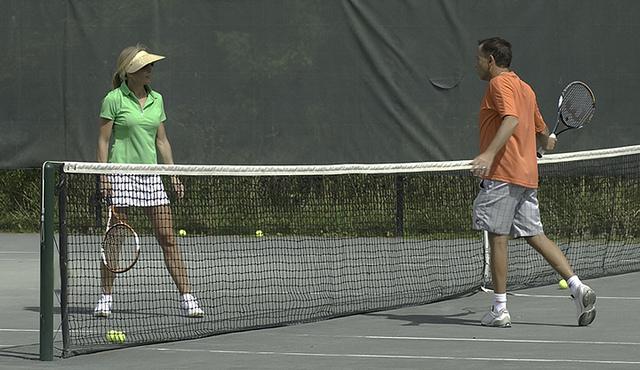How many balls can you count?
Answer briefly. 4. Are these two playing tennis?
Short answer required. Yes. What color is the player's hat?
Concise answer only. Yellow. Which player's clothes and accessories are better coordinated?
Short answer required. Woman. What color shirt is the woman wearing?
Concise answer only. Green. 